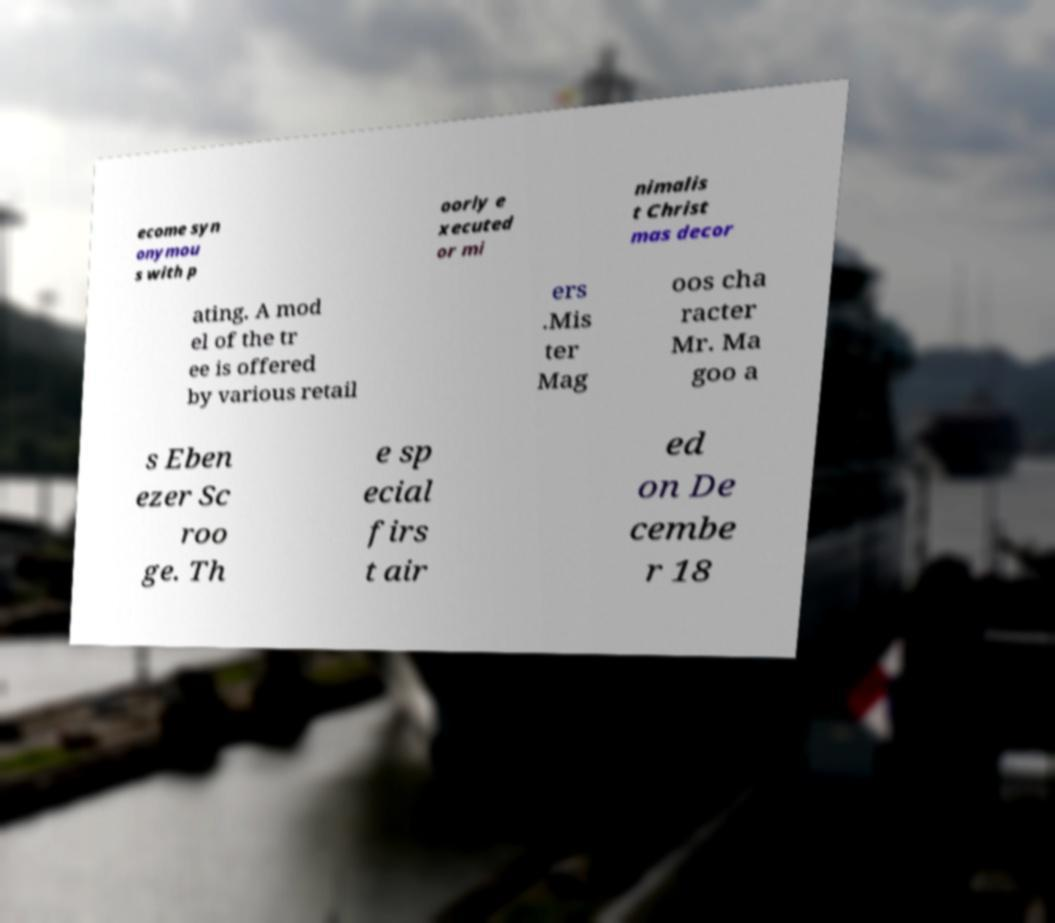There's text embedded in this image that I need extracted. Can you transcribe it verbatim? ecome syn onymou s with p oorly e xecuted or mi nimalis t Christ mas decor ating. A mod el of the tr ee is offered by various retail ers .Mis ter Mag oos cha racter Mr. Ma goo a s Eben ezer Sc roo ge. Th e sp ecial firs t air ed on De cembe r 18 